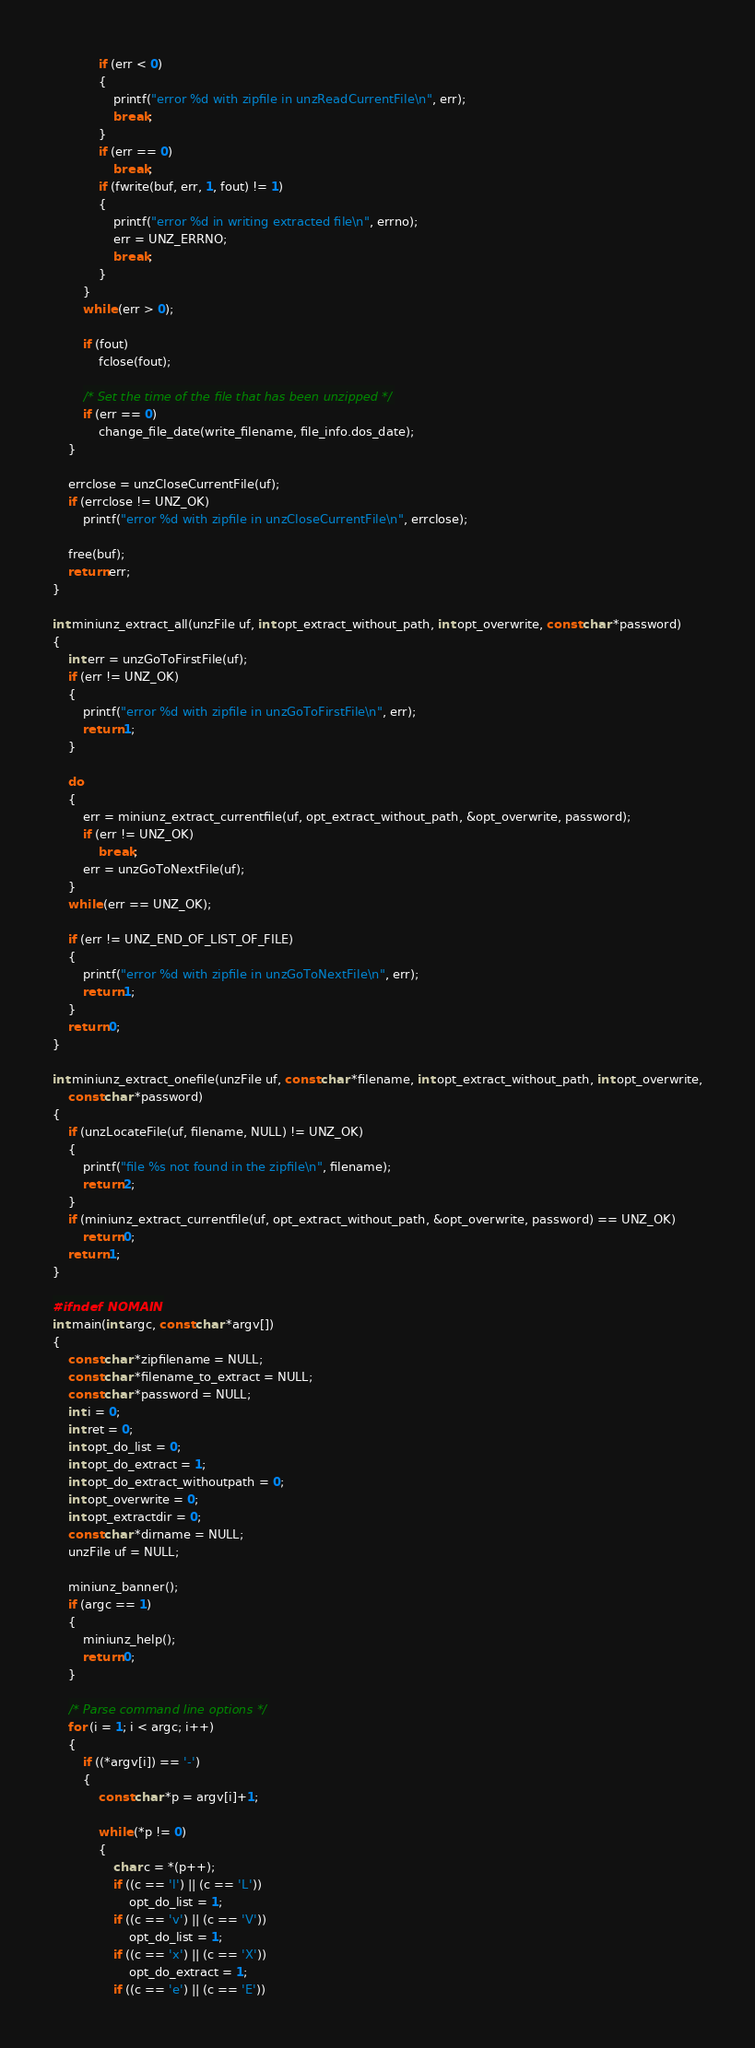<code> <loc_0><loc_0><loc_500><loc_500><_C_>            if (err < 0)
            {
                printf("error %d with zipfile in unzReadCurrentFile\n", err);
                break;
            }
            if (err == 0)
                break;
            if (fwrite(buf, err, 1, fout) != 1)
            {
                printf("error %d in writing extracted file\n", errno);
                err = UNZ_ERRNO;
                break;
            }
        }
        while (err > 0);

        if (fout)
            fclose(fout);

        /* Set the time of the file that has been unzipped */
        if (err == 0)
            change_file_date(write_filename, file_info.dos_date);
    }

    errclose = unzCloseCurrentFile(uf);
    if (errclose != UNZ_OK)
        printf("error %d with zipfile in unzCloseCurrentFile\n", errclose);

    free(buf);
    return err;
}

int miniunz_extract_all(unzFile uf, int opt_extract_without_path, int opt_overwrite, const char *password)
{
    int err = unzGoToFirstFile(uf);
    if (err != UNZ_OK)
    {
        printf("error %d with zipfile in unzGoToFirstFile\n", err);
        return 1;
    }

    do
    {
        err = miniunz_extract_currentfile(uf, opt_extract_without_path, &opt_overwrite, password);
        if (err != UNZ_OK)
            break;
        err = unzGoToNextFile(uf);
    }
    while (err == UNZ_OK);

    if (err != UNZ_END_OF_LIST_OF_FILE)
    {
        printf("error %d with zipfile in unzGoToNextFile\n", err);
        return 1;
    }
    return 0;
}

int miniunz_extract_onefile(unzFile uf, const char *filename, int opt_extract_without_path, int opt_overwrite,
    const char *password)
{
    if (unzLocateFile(uf, filename, NULL) != UNZ_OK)
    {
        printf("file %s not found in the zipfile\n", filename);
        return 2;
    }
    if (miniunz_extract_currentfile(uf, opt_extract_without_path, &opt_overwrite, password) == UNZ_OK)
        return 0;
    return 1;
}

#ifndef NOMAIN
int main(int argc, const char *argv[])
{
    const char *zipfilename = NULL;
    const char *filename_to_extract = NULL;
    const char *password = NULL;
    int i = 0;
    int ret = 0;
    int opt_do_list = 0;
    int opt_do_extract = 1;
    int opt_do_extract_withoutpath = 0;
    int opt_overwrite = 0;
    int opt_extractdir = 0;
    const char *dirname = NULL;
    unzFile uf = NULL;

    miniunz_banner();
    if (argc == 1)
    {
        miniunz_help();
        return 0;
    }

    /* Parse command line options */
    for (i = 1; i < argc; i++)
    {
        if ((*argv[i]) == '-')
        {
            const char *p = argv[i]+1;

            while (*p != 0)
            {
                char c = *(p++);
                if ((c == 'l') || (c == 'L'))
                    opt_do_list = 1;
                if ((c == 'v') || (c == 'V'))
                    opt_do_list = 1;
                if ((c == 'x') || (c == 'X'))
                    opt_do_extract = 1;
                if ((c == 'e') || (c == 'E'))</code> 